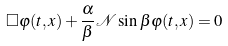<formula> <loc_0><loc_0><loc_500><loc_500>\Box \varphi ( t , x ) + \frac { \alpha } { \beta } \mathcal { N } \sin \beta \varphi ( t , x ) = 0</formula> 